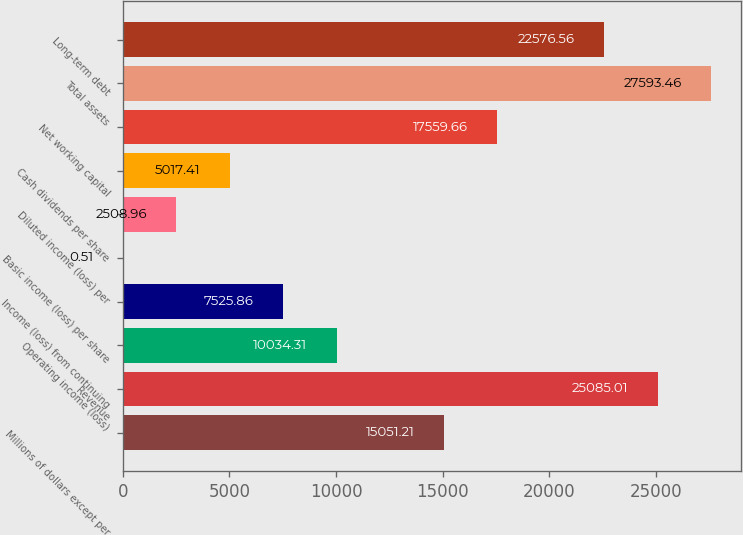<chart> <loc_0><loc_0><loc_500><loc_500><bar_chart><fcel>Millions of dollars except per<fcel>Revenue<fcel>Operating income (loss)<fcel>Income (loss) from continuing<fcel>Basic income (loss) per share<fcel>Diluted income (loss) per<fcel>Cash dividends per share<fcel>Net working capital<fcel>Total assets<fcel>Long-term debt<nl><fcel>15051.2<fcel>25085<fcel>10034.3<fcel>7525.86<fcel>0.51<fcel>2508.96<fcel>5017.41<fcel>17559.7<fcel>27593.5<fcel>22576.6<nl></chart> 